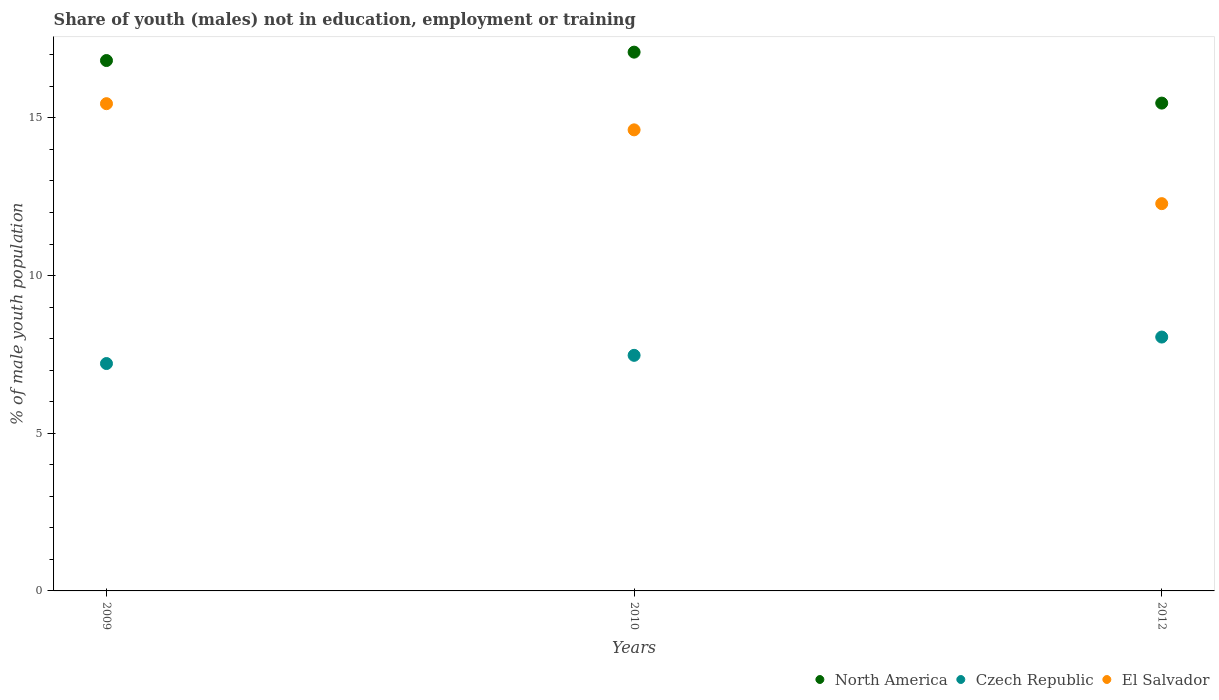What is the percentage of unemployed males population in in North America in 2012?
Offer a terse response. 15.47. Across all years, what is the maximum percentage of unemployed males population in in Czech Republic?
Your answer should be compact. 8.05. Across all years, what is the minimum percentage of unemployed males population in in Czech Republic?
Keep it short and to the point. 7.21. In which year was the percentage of unemployed males population in in Czech Republic maximum?
Your answer should be very brief. 2012. What is the total percentage of unemployed males population in in Czech Republic in the graph?
Make the answer very short. 22.73. What is the difference between the percentage of unemployed males population in in Czech Republic in 2009 and that in 2010?
Offer a very short reply. -0.26. What is the difference between the percentage of unemployed males population in in Czech Republic in 2010 and the percentage of unemployed males population in in El Salvador in 2009?
Offer a terse response. -7.98. What is the average percentage of unemployed males population in in El Salvador per year?
Give a very brief answer. 14.12. In the year 2010, what is the difference between the percentage of unemployed males population in in El Salvador and percentage of unemployed males population in in North America?
Your answer should be compact. -2.46. In how many years, is the percentage of unemployed males population in in El Salvador greater than 12 %?
Keep it short and to the point. 3. What is the ratio of the percentage of unemployed males population in in Czech Republic in 2010 to that in 2012?
Keep it short and to the point. 0.93. Is the percentage of unemployed males population in in El Salvador in 2009 less than that in 2010?
Your answer should be compact. No. Is the difference between the percentage of unemployed males population in in El Salvador in 2009 and 2010 greater than the difference between the percentage of unemployed males population in in North America in 2009 and 2010?
Offer a terse response. Yes. What is the difference between the highest and the second highest percentage of unemployed males population in in North America?
Make the answer very short. 0.27. What is the difference between the highest and the lowest percentage of unemployed males population in in El Salvador?
Offer a very short reply. 3.17. Is it the case that in every year, the sum of the percentage of unemployed males population in in El Salvador and percentage of unemployed males population in in North America  is greater than the percentage of unemployed males population in in Czech Republic?
Your answer should be compact. Yes. Does the percentage of unemployed males population in in El Salvador monotonically increase over the years?
Provide a short and direct response. No. Is the percentage of unemployed males population in in El Salvador strictly less than the percentage of unemployed males population in in North America over the years?
Provide a short and direct response. Yes. How many dotlines are there?
Give a very brief answer. 3. How many years are there in the graph?
Provide a succinct answer. 3. Are the values on the major ticks of Y-axis written in scientific E-notation?
Your answer should be very brief. No. Does the graph contain grids?
Your answer should be compact. No. How many legend labels are there?
Make the answer very short. 3. How are the legend labels stacked?
Your response must be concise. Horizontal. What is the title of the graph?
Provide a succinct answer. Share of youth (males) not in education, employment or training. What is the label or title of the X-axis?
Keep it short and to the point. Years. What is the label or title of the Y-axis?
Provide a short and direct response. % of male youth population. What is the % of male youth population in North America in 2009?
Offer a terse response. 16.82. What is the % of male youth population of Czech Republic in 2009?
Your response must be concise. 7.21. What is the % of male youth population in El Salvador in 2009?
Offer a very short reply. 15.45. What is the % of male youth population in North America in 2010?
Ensure brevity in your answer.  17.08. What is the % of male youth population of Czech Republic in 2010?
Provide a short and direct response. 7.47. What is the % of male youth population of El Salvador in 2010?
Make the answer very short. 14.62. What is the % of male youth population in North America in 2012?
Your answer should be very brief. 15.47. What is the % of male youth population in Czech Republic in 2012?
Give a very brief answer. 8.05. What is the % of male youth population in El Salvador in 2012?
Provide a short and direct response. 12.28. Across all years, what is the maximum % of male youth population in North America?
Ensure brevity in your answer.  17.08. Across all years, what is the maximum % of male youth population of Czech Republic?
Your answer should be very brief. 8.05. Across all years, what is the maximum % of male youth population in El Salvador?
Provide a succinct answer. 15.45. Across all years, what is the minimum % of male youth population of North America?
Ensure brevity in your answer.  15.47. Across all years, what is the minimum % of male youth population in Czech Republic?
Your answer should be compact. 7.21. Across all years, what is the minimum % of male youth population of El Salvador?
Provide a succinct answer. 12.28. What is the total % of male youth population of North America in the graph?
Your answer should be compact. 49.37. What is the total % of male youth population in Czech Republic in the graph?
Ensure brevity in your answer.  22.73. What is the total % of male youth population in El Salvador in the graph?
Ensure brevity in your answer.  42.35. What is the difference between the % of male youth population in North America in 2009 and that in 2010?
Your response must be concise. -0.27. What is the difference between the % of male youth population of Czech Republic in 2009 and that in 2010?
Keep it short and to the point. -0.26. What is the difference between the % of male youth population in El Salvador in 2009 and that in 2010?
Your answer should be compact. 0.83. What is the difference between the % of male youth population in North America in 2009 and that in 2012?
Ensure brevity in your answer.  1.35. What is the difference between the % of male youth population in Czech Republic in 2009 and that in 2012?
Make the answer very short. -0.84. What is the difference between the % of male youth population of El Salvador in 2009 and that in 2012?
Offer a very short reply. 3.17. What is the difference between the % of male youth population in North America in 2010 and that in 2012?
Make the answer very short. 1.62. What is the difference between the % of male youth population of Czech Republic in 2010 and that in 2012?
Your answer should be compact. -0.58. What is the difference between the % of male youth population in El Salvador in 2010 and that in 2012?
Make the answer very short. 2.34. What is the difference between the % of male youth population in North America in 2009 and the % of male youth population in Czech Republic in 2010?
Offer a terse response. 9.35. What is the difference between the % of male youth population in North America in 2009 and the % of male youth population in El Salvador in 2010?
Give a very brief answer. 2.2. What is the difference between the % of male youth population in Czech Republic in 2009 and the % of male youth population in El Salvador in 2010?
Offer a terse response. -7.41. What is the difference between the % of male youth population of North America in 2009 and the % of male youth population of Czech Republic in 2012?
Your response must be concise. 8.77. What is the difference between the % of male youth population of North America in 2009 and the % of male youth population of El Salvador in 2012?
Give a very brief answer. 4.54. What is the difference between the % of male youth population of Czech Republic in 2009 and the % of male youth population of El Salvador in 2012?
Offer a terse response. -5.07. What is the difference between the % of male youth population of North America in 2010 and the % of male youth population of Czech Republic in 2012?
Provide a short and direct response. 9.03. What is the difference between the % of male youth population in North America in 2010 and the % of male youth population in El Salvador in 2012?
Make the answer very short. 4.8. What is the difference between the % of male youth population in Czech Republic in 2010 and the % of male youth population in El Salvador in 2012?
Provide a short and direct response. -4.81. What is the average % of male youth population in North America per year?
Your answer should be compact. 16.46. What is the average % of male youth population in Czech Republic per year?
Provide a short and direct response. 7.58. What is the average % of male youth population of El Salvador per year?
Provide a short and direct response. 14.12. In the year 2009, what is the difference between the % of male youth population of North America and % of male youth population of Czech Republic?
Your response must be concise. 9.61. In the year 2009, what is the difference between the % of male youth population in North America and % of male youth population in El Salvador?
Your answer should be very brief. 1.37. In the year 2009, what is the difference between the % of male youth population in Czech Republic and % of male youth population in El Salvador?
Your answer should be compact. -8.24. In the year 2010, what is the difference between the % of male youth population of North America and % of male youth population of Czech Republic?
Keep it short and to the point. 9.61. In the year 2010, what is the difference between the % of male youth population in North America and % of male youth population in El Salvador?
Ensure brevity in your answer.  2.46. In the year 2010, what is the difference between the % of male youth population of Czech Republic and % of male youth population of El Salvador?
Give a very brief answer. -7.15. In the year 2012, what is the difference between the % of male youth population in North America and % of male youth population in Czech Republic?
Your answer should be compact. 7.42. In the year 2012, what is the difference between the % of male youth population in North America and % of male youth population in El Salvador?
Keep it short and to the point. 3.19. In the year 2012, what is the difference between the % of male youth population of Czech Republic and % of male youth population of El Salvador?
Give a very brief answer. -4.23. What is the ratio of the % of male youth population in North America in 2009 to that in 2010?
Ensure brevity in your answer.  0.98. What is the ratio of the % of male youth population of Czech Republic in 2009 to that in 2010?
Offer a terse response. 0.97. What is the ratio of the % of male youth population of El Salvador in 2009 to that in 2010?
Your answer should be compact. 1.06. What is the ratio of the % of male youth population of North America in 2009 to that in 2012?
Your answer should be very brief. 1.09. What is the ratio of the % of male youth population of Czech Republic in 2009 to that in 2012?
Give a very brief answer. 0.9. What is the ratio of the % of male youth population of El Salvador in 2009 to that in 2012?
Provide a short and direct response. 1.26. What is the ratio of the % of male youth population of North America in 2010 to that in 2012?
Offer a very short reply. 1.1. What is the ratio of the % of male youth population in Czech Republic in 2010 to that in 2012?
Ensure brevity in your answer.  0.93. What is the ratio of the % of male youth population of El Salvador in 2010 to that in 2012?
Ensure brevity in your answer.  1.19. What is the difference between the highest and the second highest % of male youth population in North America?
Give a very brief answer. 0.27. What is the difference between the highest and the second highest % of male youth population in Czech Republic?
Ensure brevity in your answer.  0.58. What is the difference between the highest and the second highest % of male youth population in El Salvador?
Keep it short and to the point. 0.83. What is the difference between the highest and the lowest % of male youth population in North America?
Your answer should be very brief. 1.62. What is the difference between the highest and the lowest % of male youth population of Czech Republic?
Your response must be concise. 0.84. What is the difference between the highest and the lowest % of male youth population in El Salvador?
Ensure brevity in your answer.  3.17. 